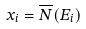Convert formula to latex. <formula><loc_0><loc_0><loc_500><loc_500>x _ { i } = \overline { N } ( E _ { i } )</formula> 